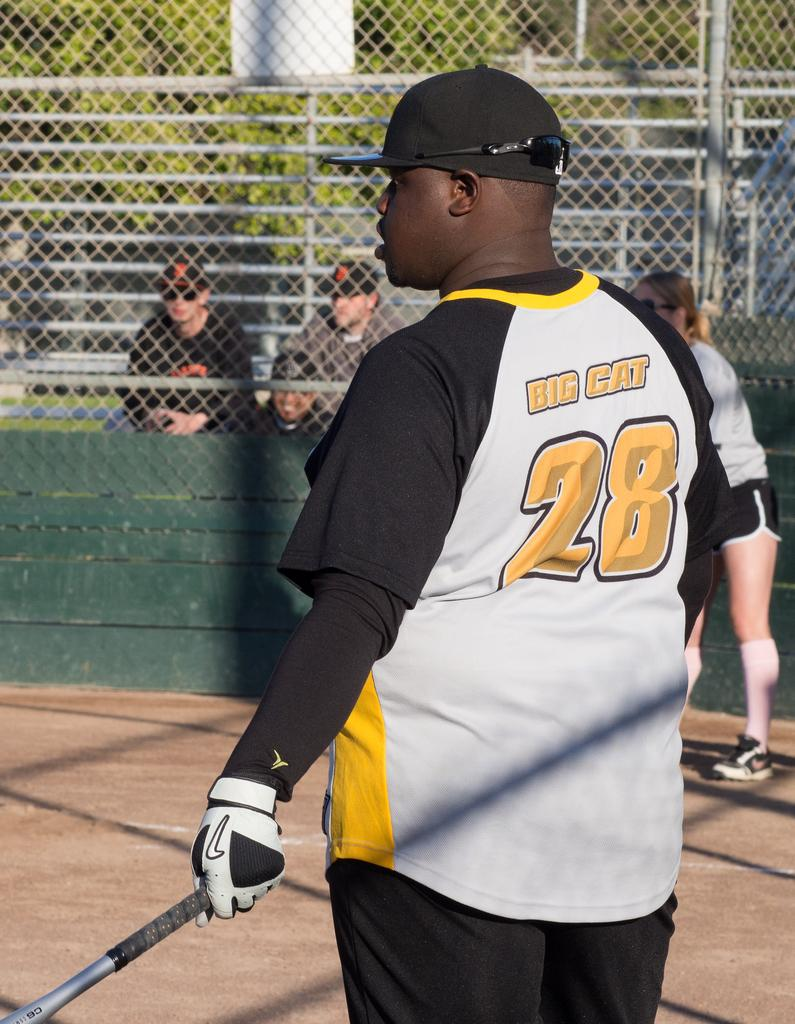<image>
Write a terse but informative summary of the picture. A man has a jersey on with the number 28 on the back of it. 